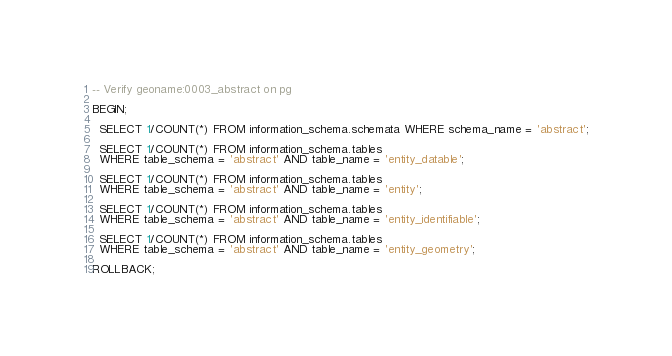Convert code to text. <code><loc_0><loc_0><loc_500><loc_500><_SQL_>-- Verify geoname:0003_abstract on pg

BEGIN;

  SELECT 1/COUNT(*) FROM information_schema.schemata WHERE schema_name = 'abstract';

  SELECT 1/COUNT(*) FROM information_schema.tables
  WHERE table_schema = 'abstract' AND table_name = 'entity_datable';

  SELECT 1/COUNT(*) FROM information_schema.tables
  WHERE table_schema = 'abstract' AND table_name = 'entity';

  SELECT 1/COUNT(*) FROM information_schema.tables
  WHERE table_schema = 'abstract' AND table_name = 'entity_identifiable';

  SELECT 1/COUNT(*) FROM information_schema.tables
  WHERE table_schema = 'abstract' AND table_name = 'entity_geometry';

ROLLBACK;
</code> 